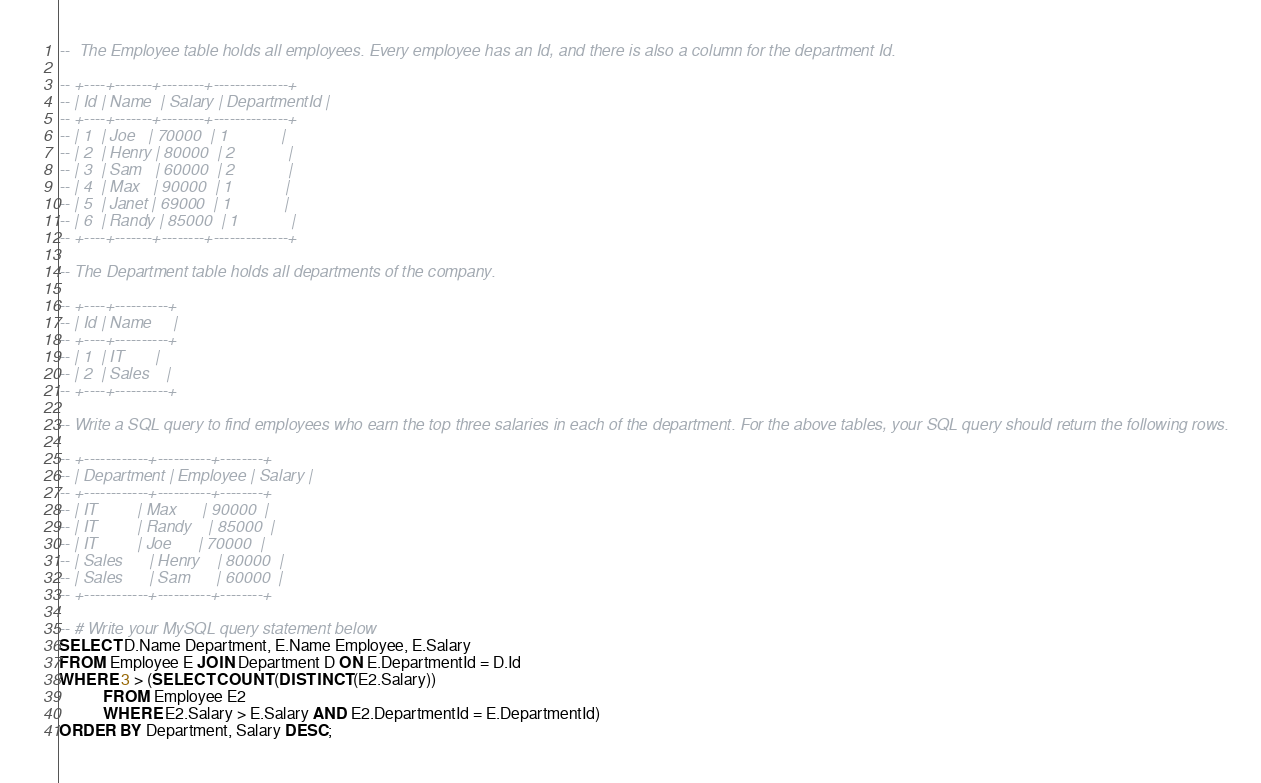Convert code to text. <code><loc_0><loc_0><loc_500><loc_500><_SQL_>--  The Employee table holds all employees. Every employee has an Id, and there is also a column for the department Id.

-- +----+-------+--------+--------------+
-- | Id | Name  | Salary | DepartmentId |
-- +----+-------+--------+--------------+
-- | 1  | Joe   | 70000  | 1            |
-- | 2  | Henry | 80000  | 2            |
-- | 3  | Sam   | 60000  | 2            |
-- | 4  | Max   | 90000  | 1            |
-- | 5  | Janet | 69000  | 1            |
-- | 6  | Randy | 85000  | 1            |
-- +----+-------+--------+--------------+

-- The Department table holds all departments of the company.

-- +----+----------+
-- | Id | Name     |
-- +----+----------+
-- | 1  | IT       |
-- | 2  | Sales    |
-- +----+----------+

-- Write a SQL query to find employees who earn the top three salaries in each of the department. For the above tables, your SQL query should return the following rows.

-- +------------+----------+--------+
-- | Department | Employee | Salary |
-- +------------+----------+--------+
-- | IT         | Max      | 90000  |
-- | IT         | Randy    | 85000  |
-- | IT         | Joe      | 70000  |
-- | Sales      | Henry    | 80000  |
-- | Sales      | Sam      | 60000  |
-- +------------+----------+--------+

-- # Write your MySQL query statement below
SELECT D.Name Department, E.Name Employee, E.Salary
FROM Employee E JOIN Department D ON E.DepartmentId = D.Id
WHERE 3 > (SELECT COUNT(DISTINCT(E2.Salary))
           FROM Employee E2
           WHERE E2.Salary > E.Salary AND E2.DepartmentId = E.DepartmentId)
ORDER BY Department, Salary DESC;</code> 